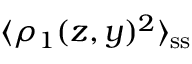<formula> <loc_0><loc_0><loc_500><loc_500>\langle \rho _ { 1 } ( z , y ) ^ { 2 } \rangle _ { s s }</formula> 